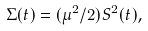<formula> <loc_0><loc_0><loc_500><loc_500>\Sigma ( t ) = ( \mu ^ { 2 } / 2 ) S ^ { 2 } ( t ) ,</formula> 